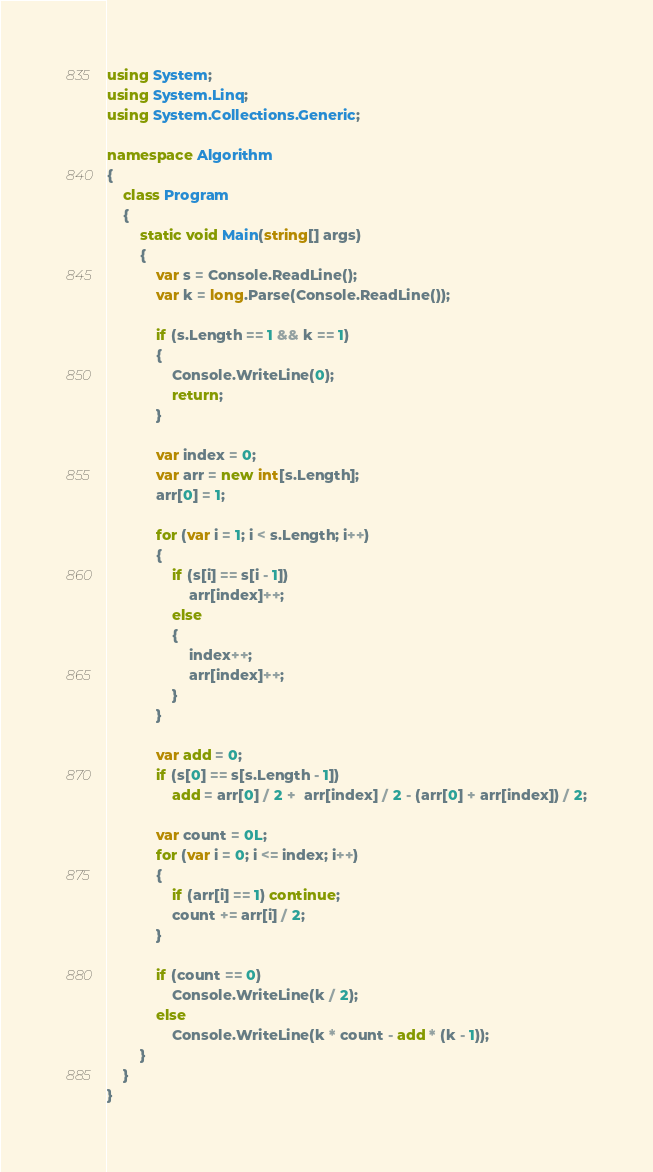Convert code to text. <code><loc_0><loc_0><loc_500><loc_500><_C#_>using System;
using System.Linq;
using System.Collections.Generic;

namespace Algorithm
{
    class Program
    {
        static void Main(string[] args)
        {
            var s = Console.ReadLine();
            var k = long.Parse(Console.ReadLine());

            if (s.Length == 1 && k == 1)
            {
                Console.WriteLine(0);
                return;
            }

            var index = 0;
            var arr = new int[s.Length];
            arr[0] = 1;
            
            for (var i = 1; i < s.Length; i++)
            {
                if (s[i] == s[i - 1])
                    arr[index]++;
                else
                {
                    index++;
                    arr[index]++;
                }
            }

            var add = 0;
            if (s[0] == s[s.Length - 1])
                add = arr[0] / 2 +  arr[index] / 2 - (arr[0] + arr[index]) / 2;

            var count = 0L;
            for (var i = 0; i <= index; i++)
            {
                if (arr[i] == 1) continue;
                count += arr[i] / 2;
            }

            if (count == 0)
                Console.WriteLine(k / 2);
            else
                Console.WriteLine(k * count - add * (k - 1));
        }
    }
}
</code> 